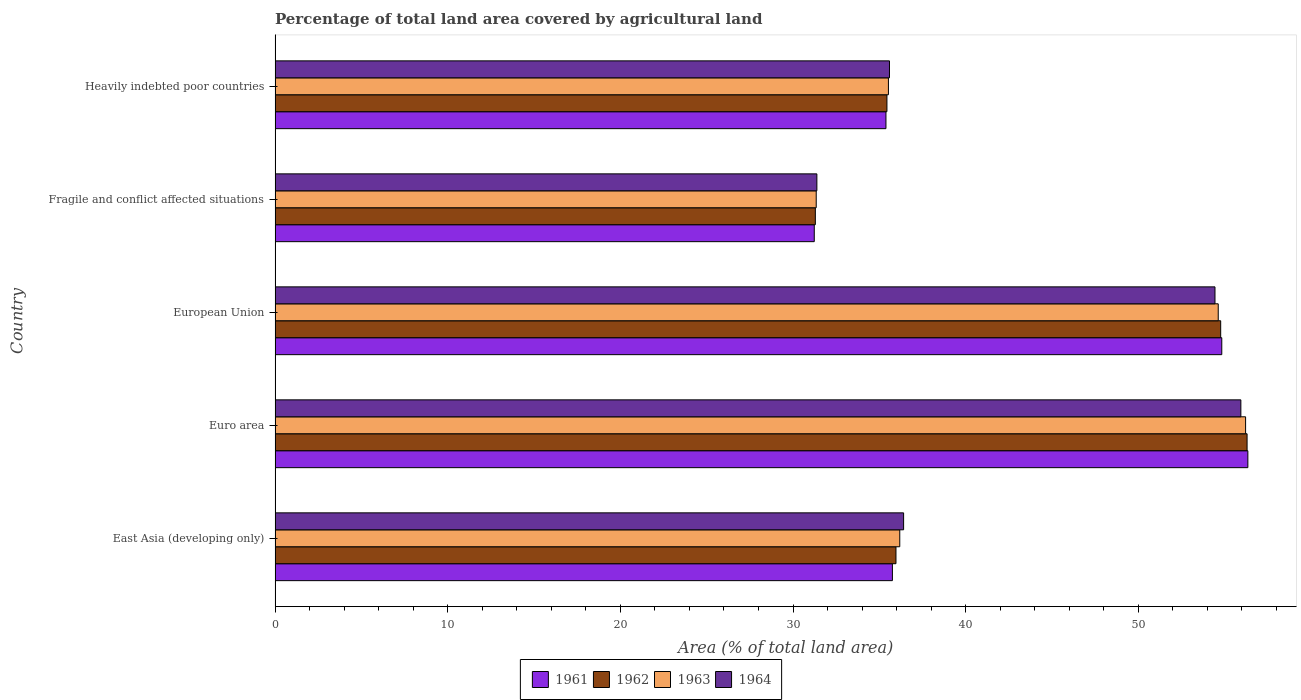How many different coloured bars are there?
Keep it short and to the point. 4. Are the number of bars on each tick of the Y-axis equal?
Offer a terse response. Yes. How many bars are there on the 3rd tick from the top?
Your response must be concise. 4. What is the label of the 5th group of bars from the top?
Give a very brief answer. East Asia (developing only). What is the percentage of agricultural land in 1962 in Euro area?
Offer a very short reply. 56.3. Across all countries, what is the maximum percentage of agricultural land in 1963?
Your answer should be compact. 56.21. Across all countries, what is the minimum percentage of agricultural land in 1961?
Make the answer very short. 31.23. In which country was the percentage of agricultural land in 1964 maximum?
Provide a short and direct response. Euro area. In which country was the percentage of agricultural land in 1961 minimum?
Offer a terse response. Fragile and conflict affected situations. What is the total percentage of agricultural land in 1961 in the graph?
Keep it short and to the point. 213.54. What is the difference between the percentage of agricultural land in 1963 in Euro area and that in Heavily indebted poor countries?
Offer a terse response. 20.69. What is the difference between the percentage of agricultural land in 1964 in Fragile and conflict affected situations and the percentage of agricultural land in 1963 in East Asia (developing only)?
Give a very brief answer. -4.8. What is the average percentage of agricultural land in 1963 per country?
Your response must be concise. 42.78. What is the difference between the percentage of agricultural land in 1961 and percentage of agricultural land in 1962 in Fragile and conflict affected situations?
Ensure brevity in your answer.  -0.06. What is the ratio of the percentage of agricultural land in 1962 in Euro area to that in Fragile and conflict affected situations?
Your answer should be compact. 1.8. Is the percentage of agricultural land in 1962 in East Asia (developing only) less than that in European Union?
Provide a short and direct response. Yes. Is the difference between the percentage of agricultural land in 1961 in Euro area and Fragile and conflict affected situations greater than the difference between the percentage of agricultural land in 1962 in Euro area and Fragile and conflict affected situations?
Ensure brevity in your answer.  Yes. What is the difference between the highest and the second highest percentage of agricultural land in 1962?
Offer a terse response. 1.53. What is the difference between the highest and the lowest percentage of agricultural land in 1963?
Keep it short and to the point. 24.87. Is the sum of the percentage of agricultural land in 1961 in East Asia (developing only) and Heavily indebted poor countries greater than the maximum percentage of agricultural land in 1964 across all countries?
Your response must be concise. Yes. Is it the case that in every country, the sum of the percentage of agricultural land in 1963 and percentage of agricultural land in 1961 is greater than the sum of percentage of agricultural land in 1964 and percentage of agricultural land in 1962?
Your response must be concise. No. What does the 3rd bar from the bottom in Euro area represents?
Provide a short and direct response. 1963. What is the difference between two consecutive major ticks on the X-axis?
Keep it short and to the point. 10. Are the values on the major ticks of X-axis written in scientific E-notation?
Make the answer very short. No. Does the graph contain grids?
Your answer should be compact. No. What is the title of the graph?
Keep it short and to the point. Percentage of total land area covered by agricultural land. What is the label or title of the X-axis?
Offer a very short reply. Area (% of total land area). What is the Area (% of total land area) in 1961 in East Asia (developing only)?
Offer a very short reply. 35.75. What is the Area (% of total land area) of 1962 in East Asia (developing only)?
Make the answer very short. 35.96. What is the Area (% of total land area) in 1963 in East Asia (developing only)?
Make the answer very short. 36.18. What is the Area (% of total land area) in 1964 in East Asia (developing only)?
Your answer should be very brief. 36.4. What is the Area (% of total land area) of 1961 in Euro area?
Your answer should be compact. 56.34. What is the Area (% of total land area) in 1962 in Euro area?
Keep it short and to the point. 56.3. What is the Area (% of total land area) in 1963 in Euro area?
Your response must be concise. 56.21. What is the Area (% of total land area) of 1964 in Euro area?
Offer a terse response. 55.94. What is the Area (% of total land area) in 1961 in European Union?
Offer a very short reply. 54.83. What is the Area (% of total land area) in 1962 in European Union?
Give a very brief answer. 54.77. What is the Area (% of total land area) in 1963 in European Union?
Provide a short and direct response. 54.63. What is the Area (% of total land area) in 1964 in European Union?
Keep it short and to the point. 54.44. What is the Area (% of total land area) of 1961 in Fragile and conflict affected situations?
Your answer should be very brief. 31.23. What is the Area (% of total land area) of 1962 in Fragile and conflict affected situations?
Offer a terse response. 31.29. What is the Area (% of total land area) in 1963 in Fragile and conflict affected situations?
Give a very brief answer. 31.34. What is the Area (% of total land area) of 1964 in Fragile and conflict affected situations?
Ensure brevity in your answer.  31.38. What is the Area (% of total land area) in 1961 in Heavily indebted poor countries?
Provide a succinct answer. 35.38. What is the Area (% of total land area) in 1962 in Heavily indebted poor countries?
Ensure brevity in your answer.  35.44. What is the Area (% of total land area) of 1963 in Heavily indebted poor countries?
Offer a very short reply. 35.52. What is the Area (% of total land area) in 1964 in Heavily indebted poor countries?
Your answer should be compact. 35.59. Across all countries, what is the maximum Area (% of total land area) of 1961?
Your answer should be very brief. 56.34. Across all countries, what is the maximum Area (% of total land area) in 1962?
Offer a very short reply. 56.3. Across all countries, what is the maximum Area (% of total land area) of 1963?
Offer a very short reply. 56.21. Across all countries, what is the maximum Area (% of total land area) of 1964?
Keep it short and to the point. 55.94. Across all countries, what is the minimum Area (% of total land area) in 1961?
Offer a very short reply. 31.23. Across all countries, what is the minimum Area (% of total land area) in 1962?
Ensure brevity in your answer.  31.29. Across all countries, what is the minimum Area (% of total land area) of 1963?
Keep it short and to the point. 31.34. Across all countries, what is the minimum Area (% of total land area) of 1964?
Make the answer very short. 31.38. What is the total Area (% of total land area) of 1961 in the graph?
Keep it short and to the point. 213.54. What is the total Area (% of total land area) in 1962 in the graph?
Your answer should be very brief. 213.75. What is the total Area (% of total land area) in 1963 in the graph?
Offer a terse response. 213.88. What is the total Area (% of total land area) in 1964 in the graph?
Ensure brevity in your answer.  213.74. What is the difference between the Area (% of total land area) in 1961 in East Asia (developing only) and that in Euro area?
Provide a succinct answer. -20.59. What is the difference between the Area (% of total land area) in 1962 in East Asia (developing only) and that in Euro area?
Keep it short and to the point. -20.34. What is the difference between the Area (% of total land area) of 1963 in East Asia (developing only) and that in Euro area?
Provide a succinct answer. -20.03. What is the difference between the Area (% of total land area) in 1964 in East Asia (developing only) and that in Euro area?
Give a very brief answer. -19.53. What is the difference between the Area (% of total land area) in 1961 in East Asia (developing only) and that in European Union?
Ensure brevity in your answer.  -19.08. What is the difference between the Area (% of total land area) in 1962 in East Asia (developing only) and that in European Union?
Make the answer very short. -18.81. What is the difference between the Area (% of total land area) in 1963 in East Asia (developing only) and that in European Union?
Make the answer very short. -18.45. What is the difference between the Area (% of total land area) of 1964 in East Asia (developing only) and that in European Union?
Give a very brief answer. -18.03. What is the difference between the Area (% of total land area) in 1961 in East Asia (developing only) and that in Fragile and conflict affected situations?
Provide a succinct answer. 4.53. What is the difference between the Area (% of total land area) in 1962 in East Asia (developing only) and that in Fragile and conflict affected situations?
Keep it short and to the point. 4.67. What is the difference between the Area (% of total land area) in 1963 in East Asia (developing only) and that in Fragile and conflict affected situations?
Your answer should be compact. 4.84. What is the difference between the Area (% of total land area) of 1964 in East Asia (developing only) and that in Fragile and conflict affected situations?
Your answer should be compact. 5.02. What is the difference between the Area (% of total land area) of 1961 in East Asia (developing only) and that in Heavily indebted poor countries?
Offer a terse response. 0.37. What is the difference between the Area (% of total land area) in 1962 in East Asia (developing only) and that in Heavily indebted poor countries?
Offer a terse response. 0.52. What is the difference between the Area (% of total land area) of 1963 in East Asia (developing only) and that in Heavily indebted poor countries?
Give a very brief answer. 0.66. What is the difference between the Area (% of total land area) of 1964 in East Asia (developing only) and that in Heavily indebted poor countries?
Keep it short and to the point. 0.82. What is the difference between the Area (% of total land area) of 1961 in Euro area and that in European Union?
Give a very brief answer. 1.51. What is the difference between the Area (% of total land area) in 1962 in Euro area and that in European Union?
Offer a terse response. 1.53. What is the difference between the Area (% of total land area) in 1963 in Euro area and that in European Union?
Your answer should be very brief. 1.58. What is the difference between the Area (% of total land area) in 1964 in Euro area and that in European Union?
Your answer should be compact. 1.5. What is the difference between the Area (% of total land area) in 1961 in Euro area and that in Fragile and conflict affected situations?
Offer a terse response. 25.11. What is the difference between the Area (% of total land area) of 1962 in Euro area and that in Fragile and conflict affected situations?
Offer a terse response. 25.01. What is the difference between the Area (% of total land area) of 1963 in Euro area and that in Fragile and conflict affected situations?
Provide a short and direct response. 24.87. What is the difference between the Area (% of total land area) of 1964 in Euro area and that in Fragile and conflict affected situations?
Ensure brevity in your answer.  24.56. What is the difference between the Area (% of total land area) in 1961 in Euro area and that in Heavily indebted poor countries?
Your answer should be compact. 20.96. What is the difference between the Area (% of total land area) in 1962 in Euro area and that in Heavily indebted poor countries?
Make the answer very short. 20.86. What is the difference between the Area (% of total land area) of 1963 in Euro area and that in Heavily indebted poor countries?
Give a very brief answer. 20.69. What is the difference between the Area (% of total land area) in 1964 in Euro area and that in Heavily indebted poor countries?
Offer a terse response. 20.35. What is the difference between the Area (% of total land area) of 1961 in European Union and that in Fragile and conflict affected situations?
Offer a terse response. 23.6. What is the difference between the Area (% of total land area) of 1962 in European Union and that in Fragile and conflict affected situations?
Your answer should be compact. 23.48. What is the difference between the Area (% of total land area) of 1963 in European Union and that in Fragile and conflict affected situations?
Make the answer very short. 23.28. What is the difference between the Area (% of total land area) of 1964 in European Union and that in Fragile and conflict affected situations?
Your answer should be compact. 23.06. What is the difference between the Area (% of total land area) in 1961 in European Union and that in Heavily indebted poor countries?
Make the answer very short. 19.45. What is the difference between the Area (% of total land area) of 1962 in European Union and that in Heavily indebted poor countries?
Keep it short and to the point. 19.33. What is the difference between the Area (% of total land area) of 1963 in European Union and that in Heavily indebted poor countries?
Provide a short and direct response. 19.1. What is the difference between the Area (% of total land area) of 1964 in European Union and that in Heavily indebted poor countries?
Give a very brief answer. 18.85. What is the difference between the Area (% of total land area) of 1961 in Fragile and conflict affected situations and that in Heavily indebted poor countries?
Make the answer very short. -4.15. What is the difference between the Area (% of total land area) of 1962 in Fragile and conflict affected situations and that in Heavily indebted poor countries?
Your answer should be very brief. -4.15. What is the difference between the Area (% of total land area) in 1963 in Fragile and conflict affected situations and that in Heavily indebted poor countries?
Your answer should be compact. -4.18. What is the difference between the Area (% of total land area) in 1964 in Fragile and conflict affected situations and that in Heavily indebted poor countries?
Offer a very short reply. -4.21. What is the difference between the Area (% of total land area) of 1961 in East Asia (developing only) and the Area (% of total land area) of 1962 in Euro area?
Offer a terse response. -20.54. What is the difference between the Area (% of total land area) of 1961 in East Asia (developing only) and the Area (% of total land area) of 1963 in Euro area?
Offer a terse response. -20.46. What is the difference between the Area (% of total land area) of 1961 in East Asia (developing only) and the Area (% of total land area) of 1964 in Euro area?
Provide a succinct answer. -20.18. What is the difference between the Area (% of total land area) of 1962 in East Asia (developing only) and the Area (% of total land area) of 1963 in Euro area?
Offer a terse response. -20.25. What is the difference between the Area (% of total land area) of 1962 in East Asia (developing only) and the Area (% of total land area) of 1964 in Euro area?
Provide a succinct answer. -19.98. What is the difference between the Area (% of total land area) of 1963 in East Asia (developing only) and the Area (% of total land area) of 1964 in Euro area?
Give a very brief answer. -19.76. What is the difference between the Area (% of total land area) in 1961 in East Asia (developing only) and the Area (% of total land area) in 1962 in European Union?
Provide a short and direct response. -19.01. What is the difference between the Area (% of total land area) of 1961 in East Asia (developing only) and the Area (% of total land area) of 1963 in European Union?
Your answer should be compact. -18.87. What is the difference between the Area (% of total land area) of 1961 in East Asia (developing only) and the Area (% of total land area) of 1964 in European Union?
Your answer should be compact. -18.68. What is the difference between the Area (% of total land area) of 1962 in East Asia (developing only) and the Area (% of total land area) of 1963 in European Union?
Ensure brevity in your answer.  -18.66. What is the difference between the Area (% of total land area) of 1962 in East Asia (developing only) and the Area (% of total land area) of 1964 in European Union?
Provide a short and direct response. -18.48. What is the difference between the Area (% of total land area) of 1963 in East Asia (developing only) and the Area (% of total land area) of 1964 in European Union?
Your response must be concise. -18.26. What is the difference between the Area (% of total land area) of 1961 in East Asia (developing only) and the Area (% of total land area) of 1962 in Fragile and conflict affected situations?
Provide a succinct answer. 4.46. What is the difference between the Area (% of total land area) of 1961 in East Asia (developing only) and the Area (% of total land area) of 1963 in Fragile and conflict affected situations?
Your answer should be compact. 4.41. What is the difference between the Area (% of total land area) of 1961 in East Asia (developing only) and the Area (% of total land area) of 1964 in Fragile and conflict affected situations?
Provide a succinct answer. 4.38. What is the difference between the Area (% of total land area) of 1962 in East Asia (developing only) and the Area (% of total land area) of 1963 in Fragile and conflict affected situations?
Your response must be concise. 4.62. What is the difference between the Area (% of total land area) of 1962 in East Asia (developing only) and the Area (% of total land area) of 1964 in Fragile and conflict affected situations?
Provide a short and direct response. 4.58. What is the difference between the Area (% of total land area) in 1963 in East Asia (developing only) and the Area (% of total land area) in 1964 in Fragile and conflict affected situations?
Your answer should be very brief. 4.8. What is the difference between the Area (% of total land area) of 1961 in East Asia (developing only) and the Area (% of total land area) of 1962 in Heavily indebted poor countries?
Provide a succinct answer. 0.32. What is the difference between the Area (% of total land area) in 1961 in East Asia (developing only) and the Area (% of total land area) in 1963 in Heavily indebted poor countries?
Give a very brief answer. 0.23. What is the difference between the Area (% of total land area) of 1961 in East Asia (developing only) and the Area (% of total land area) of 1964 in Heavily indebted poor countries?
Offer a terse response. 0.17. What is the difference between the Area (% of total land area) of 1962 in East Asia (developing only) and the Area (% of total land area) of 1963 in Heavily indebted poor countries?
Provide a succinct answer. 0.44. What is the difference between the Area (% of total land area) of 1962 in East Asia (developing only) and the Area (% of total land area) of 1964 in Heavily indebted poor countries?
Your response must be concise. 0.38. What is the difference between the Area (% of total land area) of 1963 in East Asia (developing only) and the Area (% of total land area) of 1964 in Heavily indebted poor countries?
Your response must be concise. 0.6. What is the difference between the Area (% of total land area) in 1961 in Euro area and the Area (% of total land area) in 1962 in European Union?
Make the answer very short. 1.57. What is the difference between the Area (% of total land area) in 1961 in Euro area and the Area (% of total land area) in 1963 in European Union?
Your answer should be very brief. 1.72. What is the difference between the Area (% of total land area) of 1961 in Euro area and the Area (% of total land area) of 1964 in European Union?
Offer a terse response. 1.9. What is the difference between the Area (% of total land area) in 1962 in Euro area and the Area (% of total land area) in 1963 in European Union?
Offer a terse response. 1.67. What is the difference between the Area (% of total land area) in 1962 in Euro area and the Area (% of total land area) in 1964 in European Union?
Offer a terse response. 1.86. What is the difference between the Area (% of total land area) in 1963 in Euro area and the Area (% of total land area) in 1964 in European Union?
Keep it short and to the point. 1.77. What is the difference between the Area (% of total land area) of 1961 in Euro area and the Area (% of total land area) of 1962 in Fragile and conflict affected situations?
Ensure brevity in your answer.  25.05. What is the difference between the Area (% of total land area) of 1961 in Euro area and the Area (% of total land area) of 1963 in Fragile and conflict affected situations?
Give a very brief answer. 25. What is the difference between the Area (% of total land area) in 1961 in Euro area and the Area (% of total land area) in 1964 in Fragile and conflict affected situations?
Your answer should be very brief. 24.96. What is the difference between the Area (% of total land area) in 1962 in Euro area and the Area (% of total land area) in 1963 in Fragile and conflict affected situations?
Give a very brief answer. 24.95. What is the difference between the Area (% of total land area) in 1962 in Euro area and the Area (% of total land area) in 1964 in Fragile and conflict affected situations?
Ensure brevity in your answer.  24.92. What is the difference between the Area (% of total land area) in 1963 in Euro area and the Area (% of total land area) in 1964 in Fragile and conflict affected situations?
Offer a very short reply. 24.83. What is the difference between the Area (% of total land area) of 1961 in Euro area and the Area (% of total land area) of 1962 in Heavily indebted poor countries?
Provide a short and direct response. 20.9. What is the difference between the Area (% of total land area) of 1961 in Euro area and the Area (% of total land area) of 1963 in Heavily indebted poor countries?
Keep it short and to the point. 20.82. What is the difference between the Area (% of total land area) in 1961 in Euro area and the Area (% of total land area) in 1964 in Heavily indebted poor countries?
Keep it short and to the point. 20.76. What is the difference between the Area (% of total land area) in 1962 in Euro area and the Area (% of total land area) in 1963 in Heavily indebted poor countries?
Keep it short and to the point. 20.77. What is the difference between the Area (% of total land area) of 1962 in Euro area and the Area (% of total land area) of 1964 in Heavily indebted poor countries?
Your response must be concise. 20.71. What is the difference between the Area (% of total land area) of 1963 in Euro area and the Area (% of total land area) of 1964 in Heavily indebted poor countries?
Provide a short and direct response. 20.63. What is the difference between the Area (% of total land area) of 1961 in European Union and the Area (% of total land area) of 1962 in Fragile and conflict affected situations?
Ensure brevity in your answer.  23.54. What is the difference between the Area (% of total land area) of 1961 in European Union and the Area (% of total land area) of 1963 in Fragile and conflict affected situations?
Offer a very short reply. 23.49. What is the difference between the Area (% of total land area) in 1961 in European Union and the Area (% of total land area) in 1964 in Fragile and conflict affected situations?
Your response must be concise. 23.45. What is the difference between the Area (% of total land area) of 1962 in European Union and the Area (% of total land area) of 1963 in Fragile and conflict affected situations?
Your answer should be compact. 23.43. What is the difference between the Area (% of total land area) of 1962 in European Union and the Area (% of total land area) of 1964 in Fragile and conflict affected situations?
Make the answer very short. 23.39. What is the difference between the Area (% of total land area) of 1963 in European Union and the Area (% of total land area) of 1964 in Fragile and conflict affected situations?
Ensure brevity in your answer.  23.25. What is the difference between the Area (% of total land area) of 1961 in European Union and the Area (% of total land area) of 1962 in Heavily indebted poor countries?
Provide a succinct answer. 19.39. What is the difference between the Area (% of total land area) of 1961 in European Union and the Area (% of total land area) of 1963 in Heavily indebted poor countries?
Offer a very short reply. 19.31. What is the difference between the Area (% of total land area) of 1961 in European Union and the Area (% of total land area) of 1964 in Heavily indebted poor countries?
Offer a very short reply. 19.25. What is the difference between the Area (% of total land area) of 1962 in European Union and the Area (% of total land area) of 1963 in Heavily indebted poor countries?
Your answer should be compact. 19.24. What is the difference between the Area (% of total land area) of 1962 in European Union and the Area (% of total land area) of 1964 in Heavily indebted poor countries?
Your answer should be very brief. 19.18. What is the difference between the Area (% of total land area) of 1963 in European Union and the Area (% of total land area) of 1964 in Heavily indebted poor countries?
Your answer should be compact. 19.04. What is the difference between the Area (% of total land area) of 1961 in Fragile and conflict affected situations and the Area (% of total land area) of 1962 in Heavily indebted poor countries?
Your answer should be compact. -4.21. What is the difference between the Area (% of total land area) in 1961 in Fragile and conflict affected situations and the Area (% of total land area) in 1963 in Heavily indebted poor countries?
Make the answer very short. -4.3. What is the difference between the Area (% of total land area) of 1961 in Fragile and conflict affected situations and the Area (% of total land area) of 1964 in Heavily indebted poor countries?
Offer a very short reply. -4.36. What is the difference between the Area (% of total land area) in 1962 in Fragile and conflict affected situations and the Area (% of total land area) in 1963 in Heavily indebted poor countries?
Give a very brief answer. -4.23. What is the difference between the Area (% of total land area) in 1962 in Fragile and conflict affected situations and the Area (% of total land area) in 1964 in Heavily indebted poor countries?
Provide a short and direct response. -4.29. What is the difference between the Area (% of total land area) in 1963 in Fragile and conflict affected situations and the Area (% of total land area) in 1964 in Heavily indebted poor countries?
Ensure brevity in your answer.  -4.24. What is the average Area (% of total land area) of 1961 per country?
Your response must be concise. 42.71. What is the average Area (% of total land area) in 1962 per country?
Keep it short and to the point. 42.75. What is the average Area (% of total land area) of 1963 per country?
Your response must be concise. 42.78. What is the average Area (% of total land area) in 1964 per country?
Ensure brevity in your answer.  42.75. What is the difference between the Area (% of total land area) in 1961 and Area (% of total land area) in 1962 in East Asia (developing only)?
Provide a short and direct response. -0.21. What is the difference between the Area (% of total land area) of 1961 and Area (% of total land area) of 1963 in East Asia (developing only)?
Keep it short and to the point. -0.43. What is the difference between the Area (% of total land area) of 1961 and Area (% of total land area) of 1964 in East Asia (developing only)?
Your answer should be compact. -0.65. What is the difference between the Area (% of total land area) in 1962 and Area (% of total land area) in 1963 in East Asia (developing only)?
Your answer should be compact. -0.22. What is the difference between the Area (% of total land area) of 1962 and Area (% of total land area) of 1964 in East Asia (developing only)?
Give a very brief answer. -0.44. What is the difference between the Area (% of total land area) of 1963 and Area (% of total land area) of 1964 in East Asia (developing only)?
Your answer should be very brief. -0.22. What is the difference between the Area (% of total land area) in 1961 and Area (% of total land area) in 1962 in Euro area?
Provide a short and direct response. 0.05. What is the difference between the Area (% of total land area) in 1961 and Area (% of total land area) in 1963 in Euro area?
Offer a very short reply. 0.13. What is the difference between the Area (% of total land area) of 1961 and Area (% of total land area) of 1964 in Euro area?
Give a very brief answer. 0.41. What is the difference between the Area (% of total land area) of 1962 and Area (% of total land area) of 1963 in Euro area?
Offer a terse response. 0.09. What is the difference between the Area (% of total land area) of 1962 and Area (% of total land area) of 1964 in Euro area?
Offer a very short reply. 0.36. What is the difference between the Area (% of total land area) of 1963 and Area (% of total land area) of 1964 in Euro area?
Provide a short and direct response. 0.27. What is the difference between the Area (% of total land area) of 1961 and Area (% of total land area) of 1962 in European Union?
Provide a short and direct response. 0.06. What is the difference between the Area (% of total land area) in 1961 and Area (% of total land area) in 1963 in European Union?
Provide a succinct answer. 0.21. What is the difference between the Area (% of total land area) of 1961 and Area (% of total land area) of 1964 in European Union?
Offer a very short reply. 0.39. What is the difference between the Area (% of total land area) in 1962 and Area (% of total land area) in 1963 in European Union?
Your answer should be compact. 0.14. What is the difference between the Area (% of total land area) of 1962 and Area (% of total land area) of 1964 in European Union?
Your answer should be compact. 0.33. What is the difference between the Area (% of total land area) in 1963 and Area (% of total land area) in 1964 in European Union?
Give a very brief answer. 0.19. What is the difference between the Area (% of total land area) in 1961 and Area (% of total land area) in 1962 in Fragile and conflict affected situations?
Keep it short and to the point. -0.06. What is the difference between the Area (% of total land area) of 1961 and Area (% of total land area) of 1963 in Fragile and conflict affected situations?
Make the answer very short. -0.11. What is the difference between the Area (% of total land area) in 1961 and Area (% of total land area) in 1964 in Fragile and conflict affected situations?
Your answer should be very brief. -0.15. What is the difference between the Area (% of total land area) in 1962 and Area (% of total land area) in 1963 in Fragile and conflict affected situations?
Provide a short and direct response. -0.05. What is the difference between the Area (% of total land area) in 1962 and Area (% of total land area) in 1964 in Fragile and conflict affected situations?
Provide a succinct answer. -0.09. What is the difference between the Area (% of total land area) of 1963 and Area (% of total land area) of 1964 in Fragile and conflict affected situations?
Give a very brief answer. -0.04. What is the difference between the Area (% of total land area) of 1961 and Area (% of total land area) of 1962 in Heavily indebted poor countries?
Your response must be concise. -0.06. What is the difference between the Area (% of total land area) of 1961 and Area (% of total land area) of 1963 in Heavily indebted poor countries?
Offer a very short reply. -0.14. What is the difference between the Area (% of total land area) of 1961 and Area (% of total land area) of 1964 in Heavily indebted poor countries?
Provide a succinct answer. -0.2. What is the difference between the Area (% of total land area) in 1962 and Area (% of total land area) in 1963 in Heavily indebted poor countries?
Ensure brevity in your answer.  -0.09. What is the difference between the Area (% of total land area) of 1962 and Area (% of total land area) of 1964 in Heavily indebted poor countries?
Provide a succinct answer. -0.15. What is the difference between the Area (% of total land area) in 1963 and Area (% of total land area) in 1964 in Heavily indebted poor countries?
Your answer should be very brief. -0.06. What is the ratio of the Area (% of total land area) of 1961 in East Asia (developing only) to that in Euro area?
Give a very brief answer. 0.63. What is the ratio of the Area (% of total land area) in 1962 in East Asia (developing only) to that in Euro area?
Your response must be concise. 0.64. What is the ratio of the Area (% of total land area) in 1963 in East Asia (developing only) to that in Euro area?
Provide a short and direct response. 0.64. What is the ratio of the Area (% of total land area) of 1964 in East Asia (developing only) to that in Euro area?
Give a very brief answer. 0.65. What is the ratio of the Area (% of total land area) of 1961 in East Asia (developing only) to that in European Union?
Provide a succinct answer. 0.65. What is the ratio of the Area (% of total land area) of 1962 in East Asia (developing only) to that in European Union?
Your response must be concise. 0.66. What is the ratio of the Area (% of total land area) of 1963 in East Asia (developing only) to that in European Union?
Provide a succinct answer. 0.66. What is the ratio of the Area (% of total land area) in 1964 in East Asia (developing only) to that in European Union?
Ensure brevity in your answer.  0.67. What is the ratio of the Area (% of total land area) of 1961 in East Asia (developing only) to that in Fragile and conflict affected situations?
Your answer should be very brief. 1.14. What is the ratio of the Area (% of total land area) in 1962 in East Asia (developing only) to that in Fragile and conflict affected situations?
Make the answer very short. 1.15. What is the ratio of the Area (% of total land area) of 1963 in East Asia (developing only) to that in Fragile and conflict affected situations?
Keep it short and to the point. 1.15. What is the ratio of the Area (% of total land area) of 1964 in East Asia (developing only) to that in Fragile and conflict affected situations?
Ensure brevity in your answer.  1.16. What is the ratio of the Area (% of total land area) of 1961 in East Asia (developing only) to that in Heavily indebted poor countries?
Offer a very short reply. 1.01. What is the ratio of the Area (% of total land area) of 1962 in East Asia (developing only) to that in Heavily indebted poor countries?
Keep it short and to the point. 1.01. What is the ratio of the Area (% of total land area) in 1963 in East Asia (developing only) to that in Heavily indebted poor countries?
Your answer should be very brief. 1.02. What is the ratio of the Area (% of total land area) of 1961 in Euro area to that in European Union?
Your response must be concise. 1.03. What is the ratio of the Area (% of total land area) of 1962 in Euro area to that in European Union?
Ensure brevity in your answer.  1.03. What is the ratio of the Area (% of total land area) in 1963 in Euro area to that in European Union?
Keep it short and to the point. 1.03. What is the ratio of the Area (% of total land area) of 1964 in Euro area to that in European Union?
Your response must be concise. 1.03. What is the ratio of the Area (% of total land area) of 1961 in Euro area to that in Fragile and conflict affected situations?
Offer a terse response. 1.8. What is the ratio of the Area (% of total land area) in 1962 in Euro area to that in Fragile and conflict affected situations?
Give a very brief answer. 1.8. What is the ratio of the Area (% of total land area) in 1963 in Euro area to that in Fragile and conflict affected situations?
Provide a succinct answer. 1.79. What is the ratio of the Area (% of total land area) in 1964 in Euro area to that in Fragile and conflict affected situations?
Your response must be concise. 1.78. What is the ratio of the Area (% of total land area) of 1961 in Euro area to that in Heavily indebted poor countries?
Keep it short and to the point. 1.59. What is the ratio of the Area (% of total land area) of 1962 in Euro area to that in Heavily indebted poor countries?
Your response must be concise. 1.59. What is the ratio of the Area (% of total land area) of 1963 in Euro area to that in Heavily indebted poor countries?
Provide a short and direct response. 1.58. What is the ratio of the Area (% of total land area) of 1964 in Euro area to that in Heavily indebted poor countries?
Ensure brevity in your answer.  1.57. What is the ratio of the Area (% of total land area) in 1961 in European Union to that in Fragile and conflict affected situations?
Keep it short and to the point. 1.76. What is the ratio of the Area (% of total land area) in 1962 in European Union to that in Fragile and conflict affected situations?
Provide a short and direct response. 1.75. What is the ratio of the Area (% of total land area) of 1963 in European Union to that in Fragile and conflict affected situations?
Ensure brevity in your answer.  1.74. What is the ratio of the Area (% of total land area) in 1964 in European Union to that in Fragile and conflict affected situations?
Offer a terse response. 1.73. What is the ratio of the Area (% of total land area) of 1961 in European Union to that in Heavily indebted poor countries?
Your answer should be very brief. 1.55. What is the ratio of the Area (% of total land area) of 1962 in European Union to that in Heavily indebted poor countries?
Provide a succinct answer. 1.55. What is the ratio of the Area (% of total land area) of 1963 in European Union to that in Heavily indebted poor countries?
Provide a succinct answer. 1.54. What is the ratio of the Area (% of total land area) of 1964 in European Union to that in Heavily indebted poor countries?
Keep it short and to the point. 1.53. What is the ratio of the Area (% of total land area) of 1961 in Fragile and conflict affected situations to that in Heavily indebted poor countries?
Your answer should be very brief. 0.88. What is the ratio of the Area (% of total land area) in 1962 in Fragile and conflict affected situations to that in Heavily indebted poor countries?
Offer a very short reply. 0.88. What is the ratio of the Area (% of total land area) in 1963 in Fragile and conflict affected situations to that in Heavily indebted poor countries?
Provide a short and direct response. 0.88. What is the ratio of the Area (% of total land area) in 1964 in Fragile and conflict affected situations to that in Heavily indebted poor countries?
Provide a short and direct response. 0.88. What is the difference between the highest and the second highest Area (% of total land area) of 1961?
Provide a succinct answer. 1.51. What is the difference between the highest and the second highest Area (% of total land area) in 1962?
Ensure brevity in your answer.  1.53. What is the difference between the highest and the second highest Area (% of total land area) of 1963?
Your response must be concise. 1.58. What is the difference between the highest and the second highest Area (% of total land area) of 1964?
Provide a succinct answer. 1.5. What is the difference between the highest and the lowest Area (% of total land area) in 1961?
Provide a short and direct response. 25.11. What is the difference between the highest and the lowest Area (% of total land area) in 1962?
Provide a short and direct response. 25.01. What is the difference between the highest and the lowest Area (% of total land area) in 1963?
Offer a terse response. 24.87. What is the difference between the highest and the lowest Area (% of total land area) in 1964?
Provide a short and direct response. 24.56. 